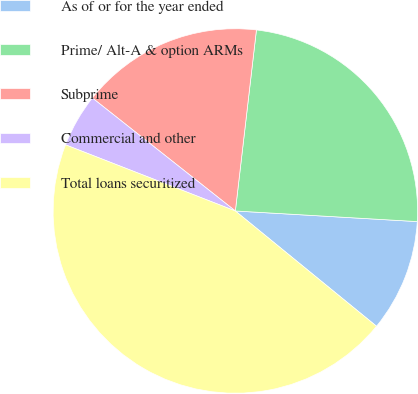<chart> <loc_0><loc_0><loc_500><loc_500><pie_chart><fcel>As of or for the year ended<fcel>Prime/ Alt-A & option ARMs<fcel>Subprime<fcel>Commercial and other<fcel>Total loans securitized<nl><fcel>9.97%<fcel>24.08%<fcel>16.2%<fcel>4.73%<fcel>45.01%<nl></chart> 